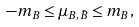<formula> <loc_0><loc_0><loc_500><loc_500>- m _ { B } \leq \mu _ { B , { \bar { B } } } \leq m _ { B } ,</formula> 